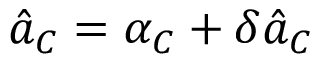<formula> <loc_0><loc_0><loc_500><loc_500>\hat { a } _ { C } = \alpha _ { C } + \delta \hat { a } _ { C }</formula> 